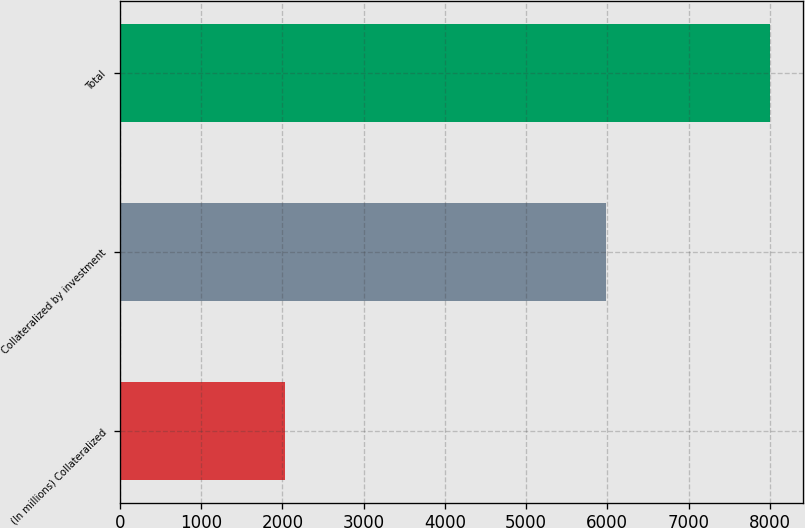<chart> <loc_0><loc_0><loc_500><loc_500><bar_chart><fcel>(In millions) Collateralized<fcel>Collateralized by investment<fcel>Total<nl><fcel>2026<fcel>5980<fcel>8006<nl></chart> 